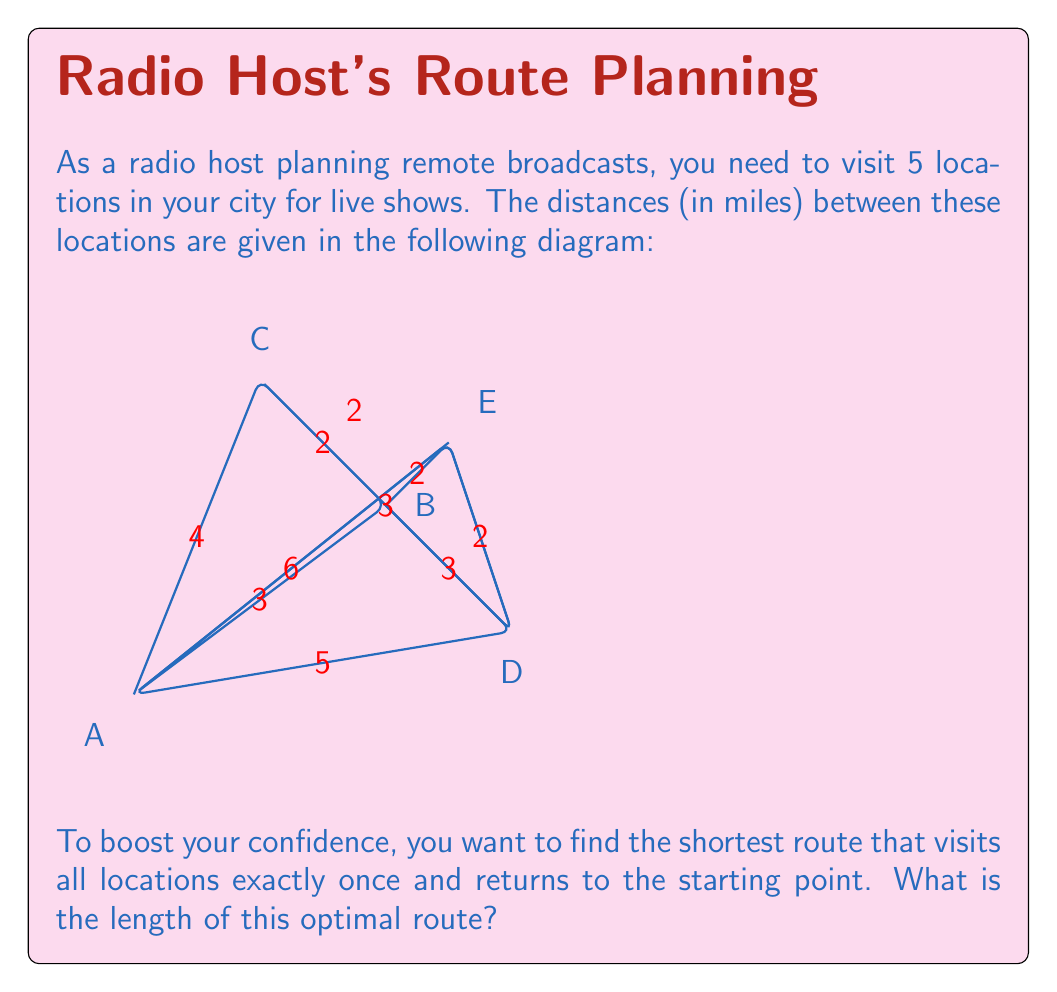Could you help me with this problem? This problem is an instance of the Traveling Salesman Problem (TSP), which is NP-hard. For a small number of locations like this, we can solve it using a brute-force approach:

1) First, we list all possible permutations of the 5 locations. There are $(5-1)! = 24$ such permutations, as we fix the starting point.

2) For each permutation, we calculate the total distance of the route, including the return to the starting point.

3) We choose the permutation with the minimum total distance.

Let's calculate for a few permutations:

A-B-C-D-E-A: $3 + 2 + 3 + 2 + 6 = 16$ miles
A-B-C-E-D-A: $3 + 2 + 2 + 2 + 5 = 14$ miles
A-B-D-E-C-A: $3 + 3 + 2 + 2 + 4 = 14$ miles
A-C-B-D-E-A: $4 + 2 + 3 + 2 + 6 = 17$ miles

After checking all 24 permutations, we find that the minimum distance is 14 miles, which can be achieved by two different routes: A-B-C-E-D-A or A-B-D-E-C-A.

This optimal route will help you visit all locations efficiently, potentially reducing travel stress and allowing more time for preparation, which can boost your confidence for the live shows.
Answer: 14 miles 